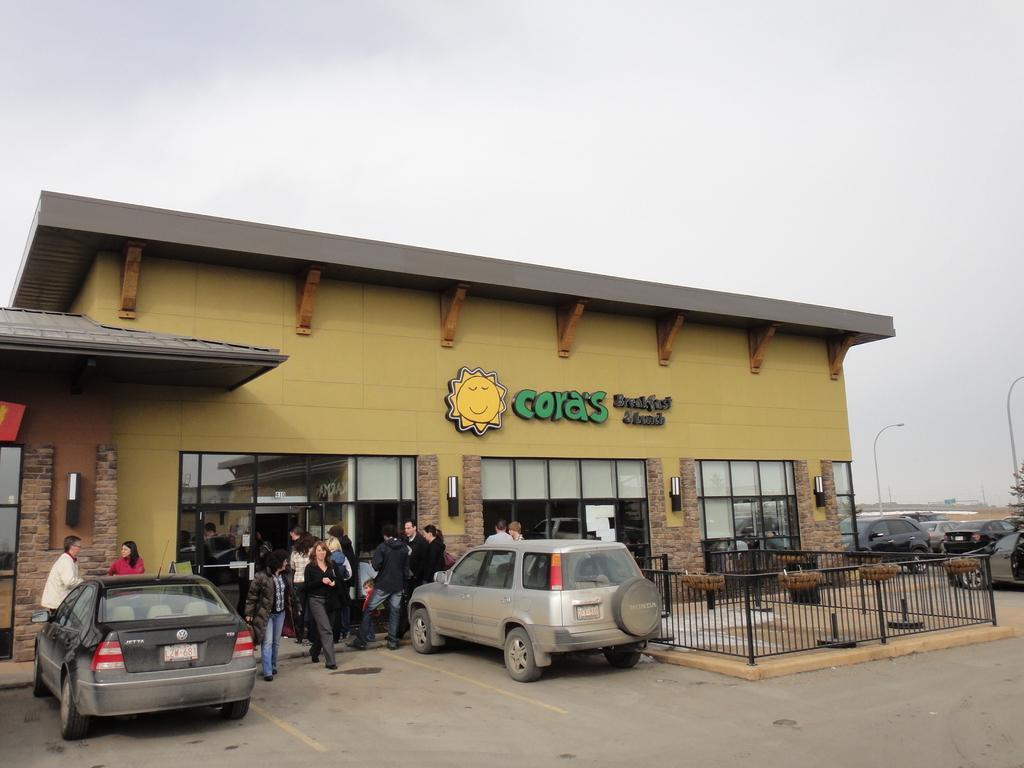Could you give a brief overview of what you see in this image? In this image I can see two vehicles in-front of the building. To the side of the vehicle I can see the group of people with different color dresses. To the right I can see the railing and few more vehicles. In the background I can see the poles and the sky. 